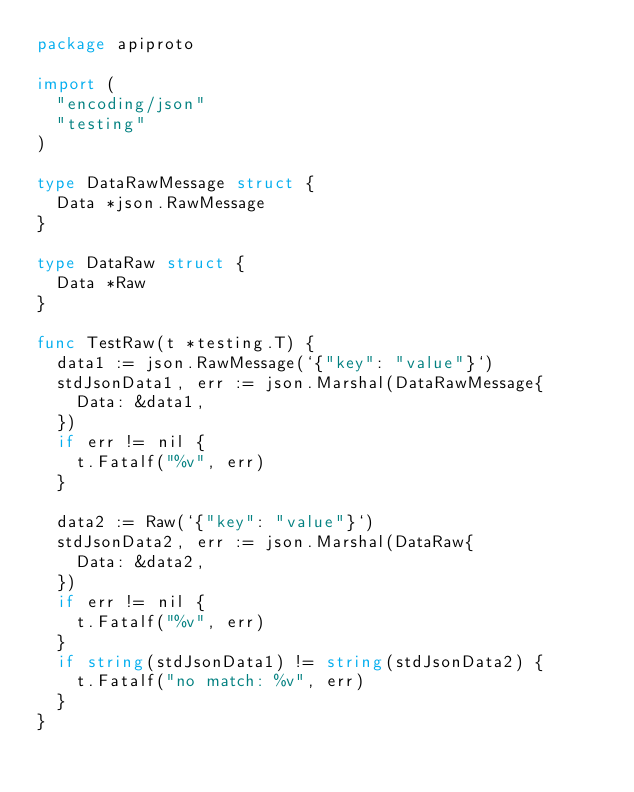<code> <loc_0><loc_0><loc_500><loc_500><_Go_>package apiproto

import (
	"encoding/json"
	"testing"
)

type DataRawMessage struct {
	Data *json.RawMessage
}

type DataRaw struct {
	Data *Raw
}

func TestRaw(t *testing.T) {
	data1 := json.RawMessage(`{"key": "value"}`)
	stdJsonData1, err := json.Marshal(DataRawMessage{
		Data: &data1,
	})
	if err != nil {
		t.Fatalf("%v", err)
	}

	data2 := Raw(`{"key": "value"}`)
	stdJsonData2, err := json.Marshal(DataRaw{
		Data: &data2,
	})
	if err != nil {
		t.Fatalf("%v", err)
	}
	if string(stdJsonData1) != string(stdJsonData2) {
		t.Fatalf("no match: %v", err)
	}
}
</code> 